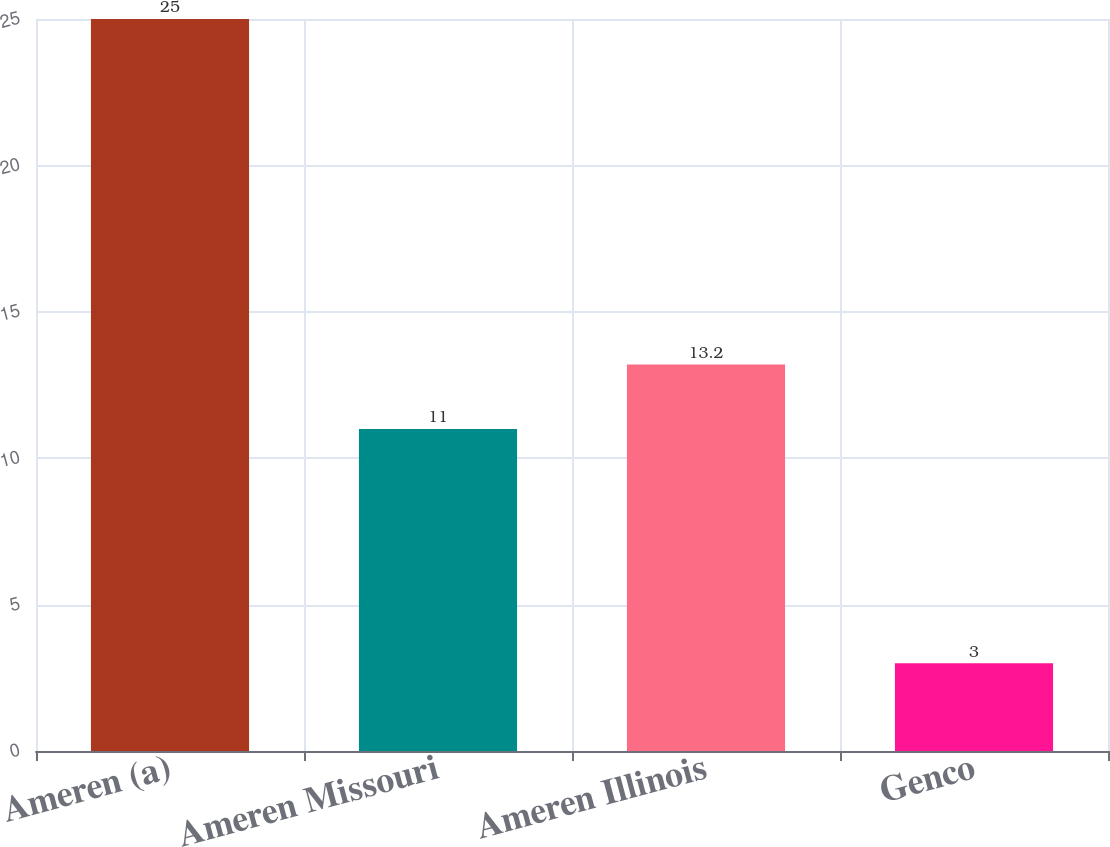Convert chart to OTSL. <chart><loc_0><loc_0><loc_500><loc_500><bar_chart><fcel>Ameren (a)<fcel>Ameren Missouri<fcel>Ameren Illinois<fcel>Genco<nl><fcel>25<fcel>11<fcel>13.2<fcel>3<nl></chart> 